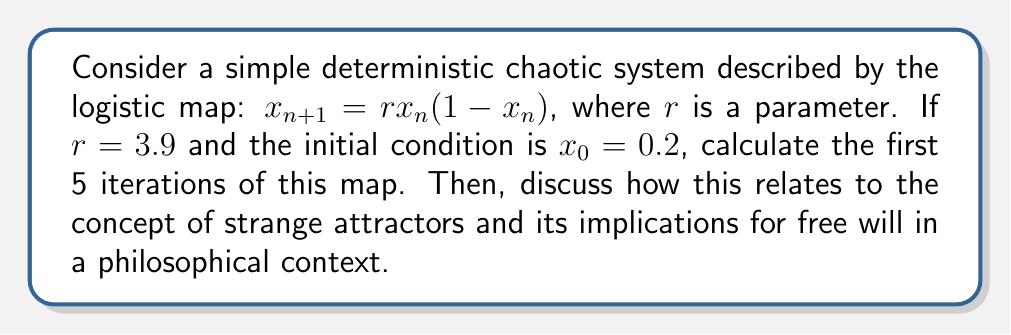Teach me how to tackle this problem. 1. The logistic map is given by $x_{n+1} = rx_n(1-x_n)$ with $r=3.9$ and $x_0=0.2$

2. Calculate the first 5 iterations:

   $x_1 = 3.9 \cdot 0.2 \cdot (1-0.2) = 0.624$
   $x_2 = 3.9 \cdot 0.624 \cdot (1-0.624) \approx 0.915$
   $x_3 = 3.9 \cdot 0.915 \cdot (1-0.915) \approx 0.303$
   $x_4 = 3.9 \cdot 0.303 \cdot (1-0.303) \approx 0.824$
   $x_5 = 3.9 \cdot 0.824 \cdot (1-0.824) \approx 0.566$

3. This system exhibits chaotic behavior, as small changes in initial conditions lead to drastically different outcomes over time.

4. A strange attractor is a geometric shape that emerges when plotting the long-term behavior of a chaotic system. For the logistic map with $r=3.9$, the strange attractor is a set of points between 0 and 1 that the system visits repeatedly but in an unpredictable order.

5. The connection to free will lies in the deterministic yet unpredictable nature of chaotic systems. While the system is fully determined by its initial conditions and governing equation, its long-term behavior is practically impossible to predict due to sensitivity to initial conditions.

6. Philosophically, this relates to the debate on compatibilism, which attempts to reconcile determinism with free will. The chaotic nature of the system could be seen as analogous to human decision-making: deterministic at its core, yet practically unpredictable and appearing "free" due to its complexity.

7. Rachael Wiseman's work on agency and action could be connected to this concept, exploring how deterministic processes at a fundamental level might give rise to what we perceive as free will and intentional action.
Answer: The first 5 iterations are approximately 0.624, 0.915, 0.303, 0.824, and 0.566. This demonstrates chaotic behavior, relating to strange attractors and suggesting a compatibilist view of free will. 